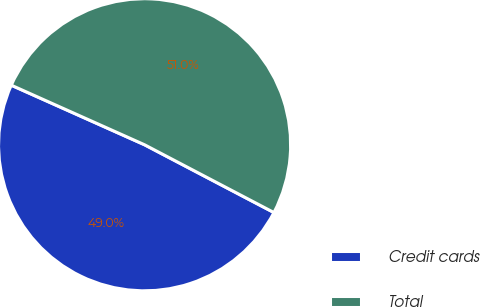Convert chart to OTSL. <chart><loc_0><loc_0><loc_500><loc_500><pie_chart><fcel>Credit cards<fcel>Total<nl><fcel>49.01%<fcel>50.99%<nl></chart> 